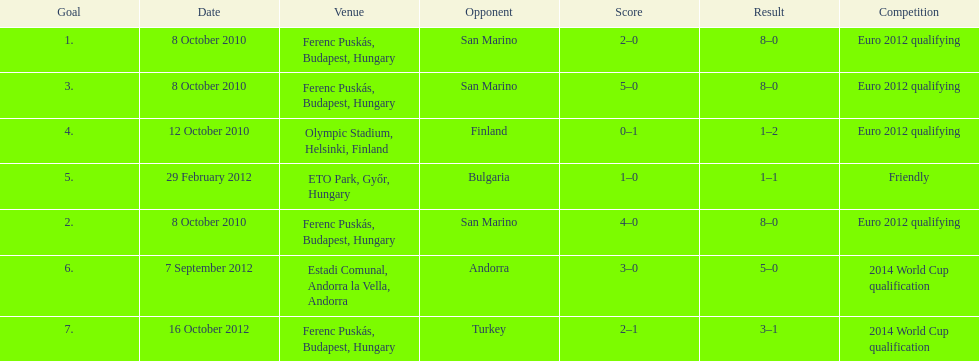How many goals were scored at the euro 2012 qualifying competition? 12. 